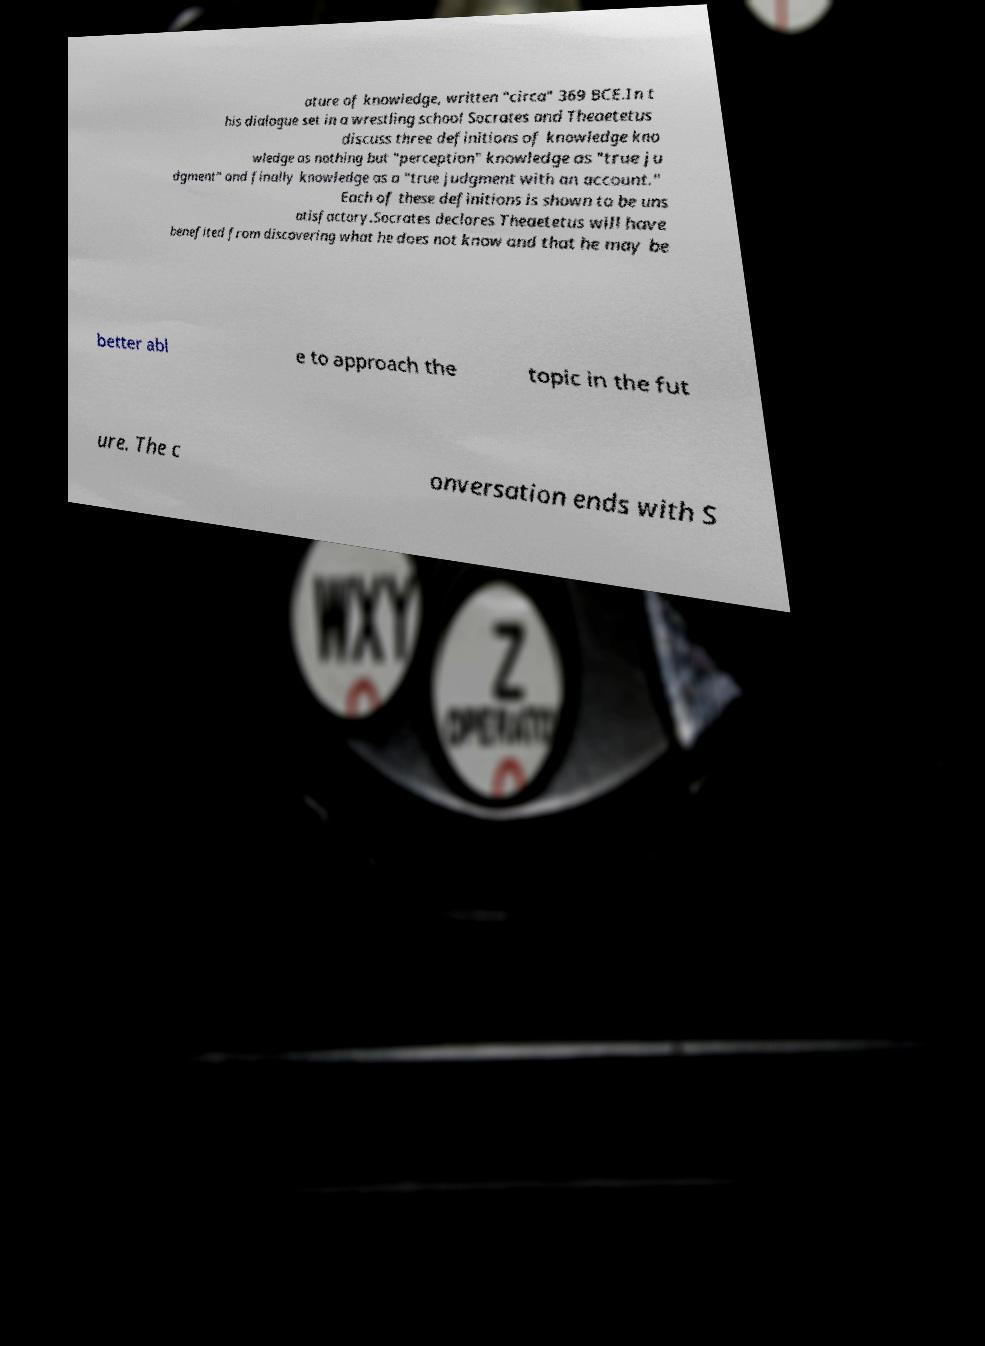Can you accurately transcribe the text from the provided image for me? ature of knowledge, written "circa" 369 BCE.In t his dialogue set in a wrestling school Socrates and Theaetetus discuss three definitions of knowledge kno wledge as nothing but "perception" knowledge as "true ju dgment" and finally knowledge as a "true judgment with an account." Each of these definitions is shown to be uns atisfactory.Socrates declares Theaetetus will have benefited from discovering what he does not know and that he may be better abl e to approach the topic in the fut ure. The c onversation ends with S 